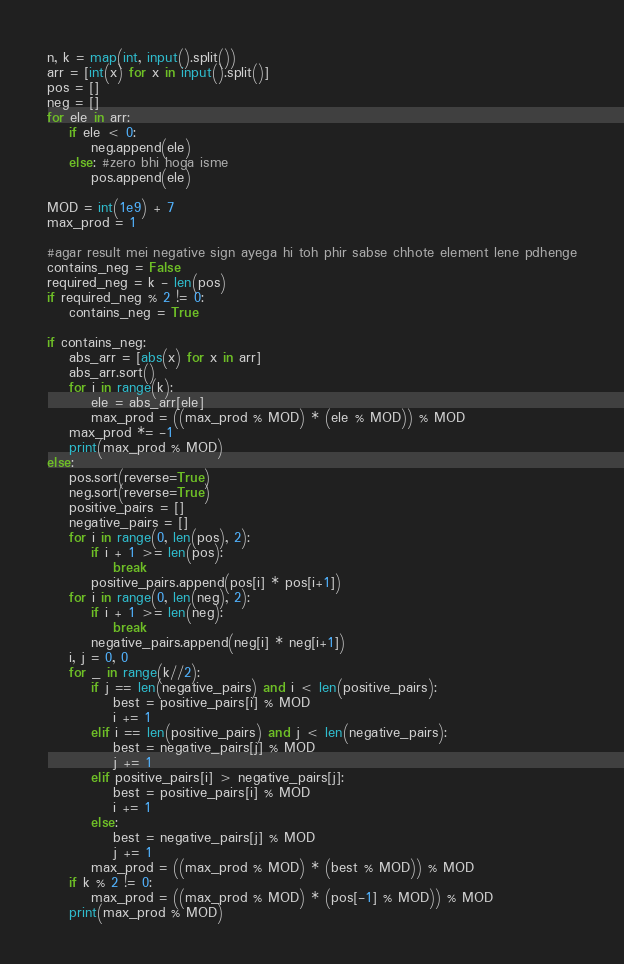<code> <loc_0><loc_0><loc_500><loc_500><_Python_>n, k = map(int, input().split())
arr = [int(x) for x in input().split()]
pos = []
neg = []
for ele in arr:
    if ele < 0:
        neg.append(ele)
    else: #zero bhi hoga isme
        pos.append(ele)

MOD = int(1e9) + 7
max_prod = 1

#agar result mei negative sign ayega hi toh phir sabse chhote element lene pdhenge
contains_neg = False
required_neg = k - len(pos)
if required_neg % 2 != 0:
    contains_neg = True

if contains_neg:
    abs_arr = [abs(x) for x in arr]
    abs_arr.sort()
    for i in range(k):
        ele = abs_arr[ele]
        max_prod = ((max_prod % MOD) * (ele % MOD)) % MOD
    max_prod *= -1
    print(max_prod % MOD)
else:
    pos.sort(reverse=True)
    neg.sort(reverse=True)
    positive_pairs = []
    negative_pairs = []
    for i in range(0, len(pos), 2):
        if i + 1 >= len(pos):
            break
        positive_pairs.append(pos[i] * pos[i+1])
    for i in range(0, len(neg), 2):
        if i + 1 >= len(neg):
            break
        negative_pairs.append(neg[i] * neg[i+1])
    i, j = 0, 0
    for _ in range(k//2):
        if j == len(negative_pairs) and i < len(positive_pairs):
            best = positive_pairs[i] % MOD
            i += 1
        elif i == len(positive_pairs) and j < len(negative_pairs):
            best = negative_pairs[j] % MOD
            j += 1
        elif positive_pairs[i] > negative_pairs[j]:
            best = positive_pairs[i] % MOD
            i += 1
        else:
            best = negative_pairs[j] % MOD
            j += 1
        max_prod = ((max_prod % MOD) * (best % MOD)) % MOD
    if k % 2 != 0:
        max_prod = ((max_prod % MOD) * (pos[-1] % MOD)) % MOD
    print(max_prod % MOD)</code> 